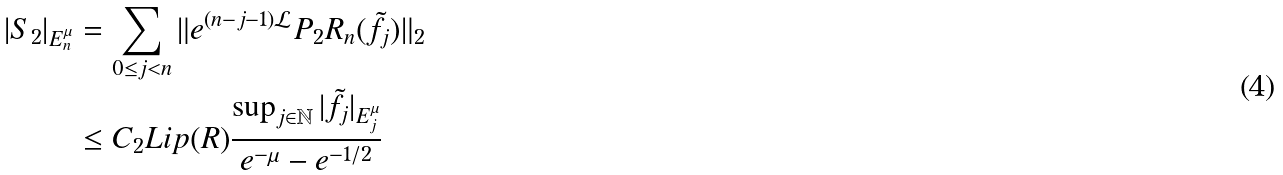Convert formula to latex. <formula><loc_0><loc_0><loc_500><loc_500>| S _ { 2 } | _ { E _ { n } ^ { \mu } } & = \sum _ { 0 \leq j < n } \| e ^ { ( n - j - 1 ) \mathcal { L } } P _ { 2 } R _ { n } ( \tilde { f } _ { j } ) \| _ { 2 } \\ & \leq C _ { 2 } L i p ( R ) \frac { \sup _ { j \in \mathbb { N } } | \tilde { f } _ { j } | _ { E _ { j } ^ { \mu } } } { e ^ { - \mu } - e ^ { - 1 / 2 } }</formula> 